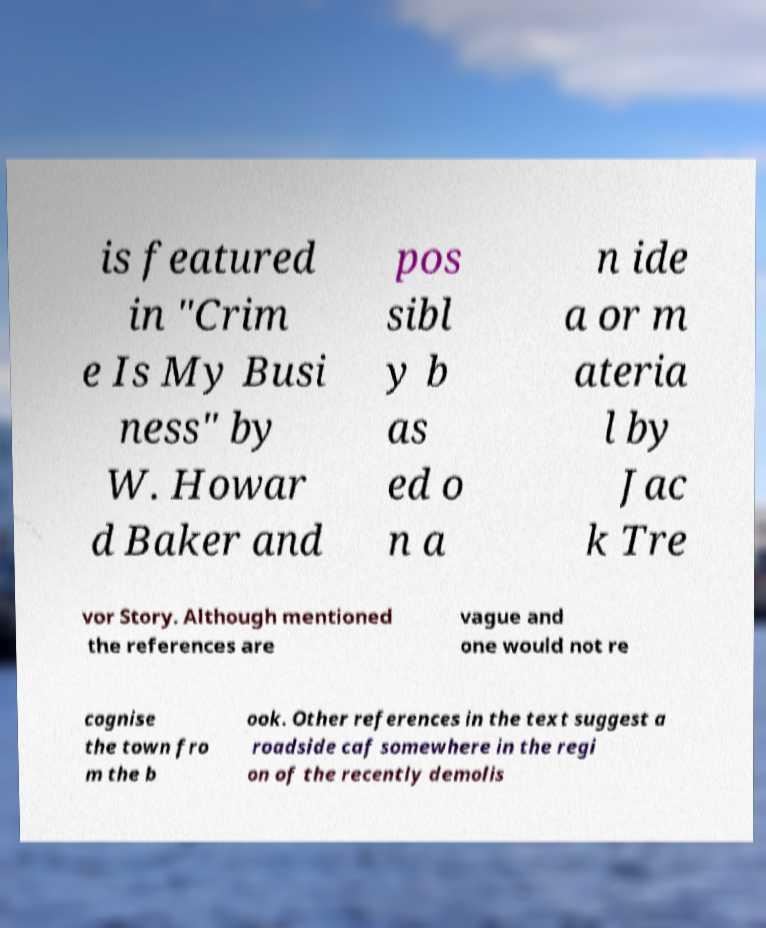I need the written content from this picture converted into text. Can you do that? is featured in "Crim e Is My Busi ness" by W. Howar d Baker and pos sibl y b as ed o n a n ide a or m ateria l by Jac k Tre vor Story. Although mentioned the references are vague and one would not re cognise the town fro m the b ook. Other references in the text suggest a roadside caf somewhere in the regi on of the recently demolis 